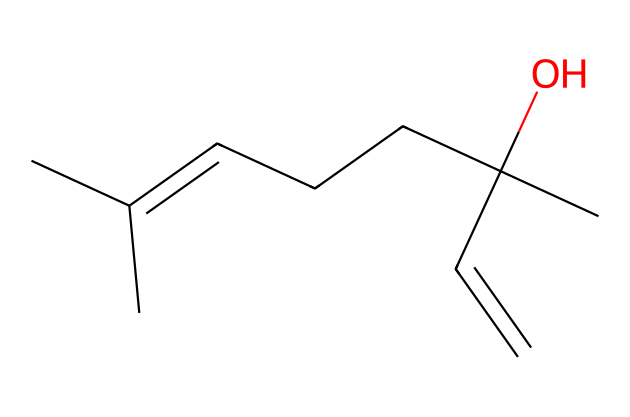what is the name of the main component represented by this structure? The SMILES representation corresponds to linalool, a compound commonly found in lavender essential oil, known for its calming effects.
Answer: linalool how many carbon atoms are present in this structure? By counting the carbon atoms in the SMILES representation, we see that there are ten carbon atoms.
Answer: ten what type of functional group is present in linalool? The presence of the hydroxyl group (-OH) in the structure indicates that linalool is an alcohol.
Answer: alcohol how many double bonds are in this chemical structure? Since the structure depicts one double bond between carbon atoms (C=C), we conclude that there is one double bond.
Answer: one what role does linalool play in stress relief? Linalool is known for its soothing fragrance and psychoactive properties that help reduce anxiety and promote relaxation, making it effective for stress relief.
Answer: stress relief is linalool a saturated or unsaturated compound? The presence of a double bond in the structure indicates that linalool is classified as an unsaturated compound due to the fewer hydrogen atoms bonded to the carbons.
Answer: unsaturated 